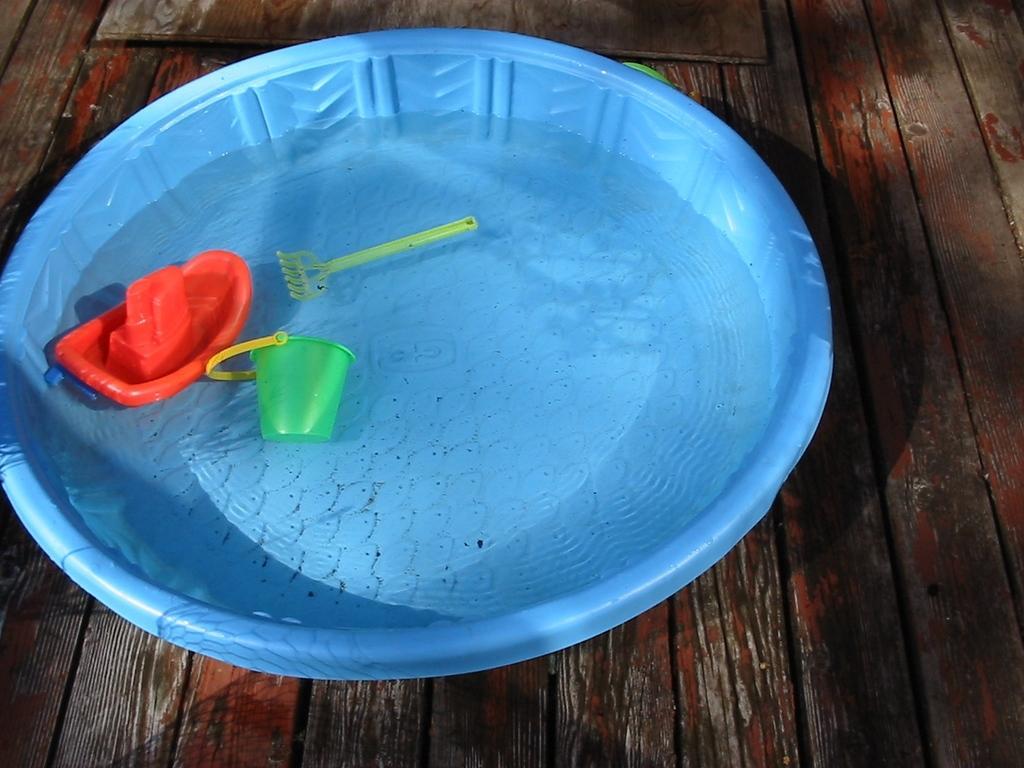Please provide a concise description of this image. In this image on the table there is water in the tub and there are a few objects in the tub. 